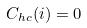<formula> <loc_0><loc_0><loc_500><loc_500>C _ { h c } ( i ) = 0</formula> 